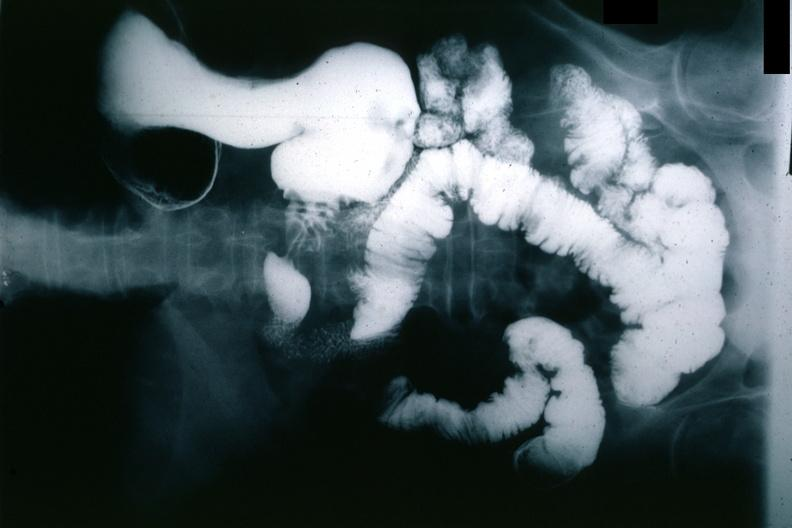where is this x-ray figure taken?
Answer the question using a single word or phrase. Gastrointestinal system 